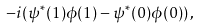Convert formula to latex. <formula><loc_0><loc_0><loc_500><loc_500>- i ( \psi ^ { * } ( 1 ) \phi ( 1 ) - \psi ^ { * } ( 0 ) \phi ( 0 ) ) \, ,</formula> 